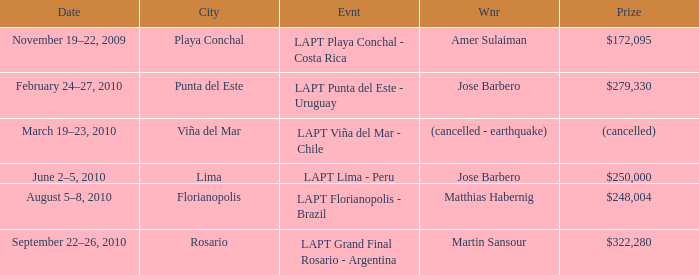What event has a $248,004 prize? LAPT Florianopolis - Brazil. 